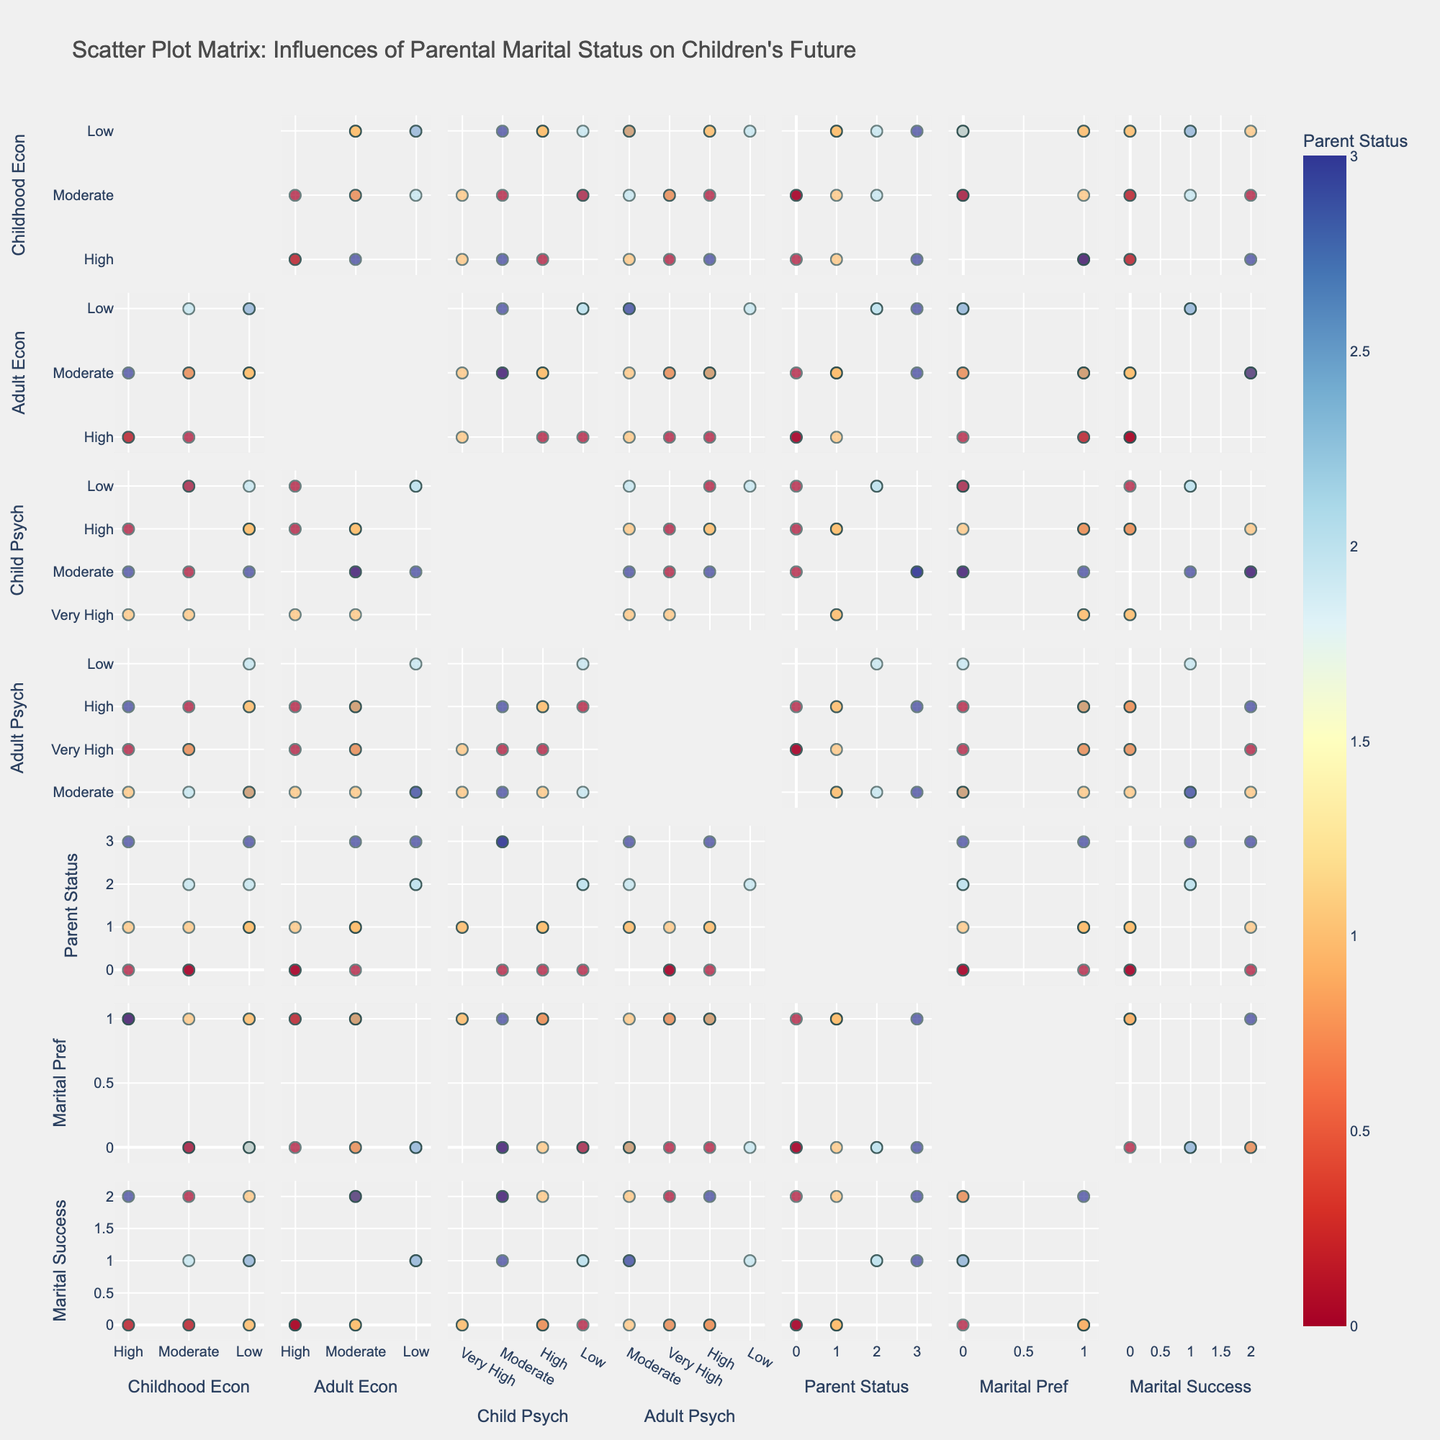What does the title of the figure suggest? The title, "Scatter Plot Matrix: Influences of Parental Marital Status on Children's Future," suggests that the figure is exploring how different parental marital statuses influence various aspects of their children's lives.
Answer: Influences of parental marital status on children's future What is the color scale used to differentiate the data points? The color scale used is a diverging scale from red to blue. This scale helps in distinguishing between different categories of parental marital status.
Answer: Red to blue How many variables are compared in the scatter plot matrix? There are seven variables compared in the scatter plot matrix: Childhood Economic Stability, Adult Economic Stability, Child Psychological Well-being, Adult Psychological Well-being, Parent Marital Status, Marital Preference, and Marital Success.
Answer: Seven Which parental marital status appears to have higher adult psychological well-being for their children? We should look for the "Adult Psych" dimension and see which colored dots (representing different parental marital statuses) are generally higher. Children with married parents tend to show higher adult psychological well-being.
Answer: Married Is there a noticeable trend between childhood economic stability and adult economic stability? To find this, observe the scatter plot between "Childhood Econ" and "Adult Econ" axes. There seems to be a positive trend, indicating that higher childhood economic stability often leads to higher adult economic stability.
Answer: Positive trend What type of marital preference is more common among children of divorced parents? By looking at the scatter plots that involve "Parent Status" and "Marital Pref" dimensions, we can see that children of divorced parents are more likely to have non-traditional marital preferences.
Answer: Non-traditional Do children with high adult economic stability also have high adult psychological well-being? Observe the scatter plot between "Adult Econ" and "Adult Psych". Many of the higher points in "Adult Econ" also correlate with higher points in "Adult Psych", indicating a positive relationship.
Answer: Yes Which combination shows a higher variance: childhood psychological well-being versus adult psychological well-being, or childhood economic stability versus adult economic stability? By examining the spread of data points in respective scatter plots, the "Child Psych" vs "Adult Psych" scatter plot shows a higher variance compared to "Childhood Econ" vs "Adult Econ".
Answer: Childhood Psych vs Adult Psych Does marital success correlate more strongly with childhood economic stability or adult economic stability? By comparing the scatter plots of "Childhood Econ" vs "Marital Success" and "Adult Econ" vs "Marital Success", the points are more tightly clustered around a line in "Adult Econ" vs "Marital Success", indicating a stronger correlation.
Answer: Adult economic stability Which combination has the least overlap: parent marital status and marital preference, or parent marital status and marital success? Looking at the scatter plots, the combination of "Parent Status" and "Marital Pref" shows less overlap compared to "Parent Status" and "Marital Success".
Answer: Parent marital status and marital preference 